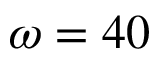<formula> <loc_0><loc_0><loc_500><loc_500>\omega = 4 0</formula> 